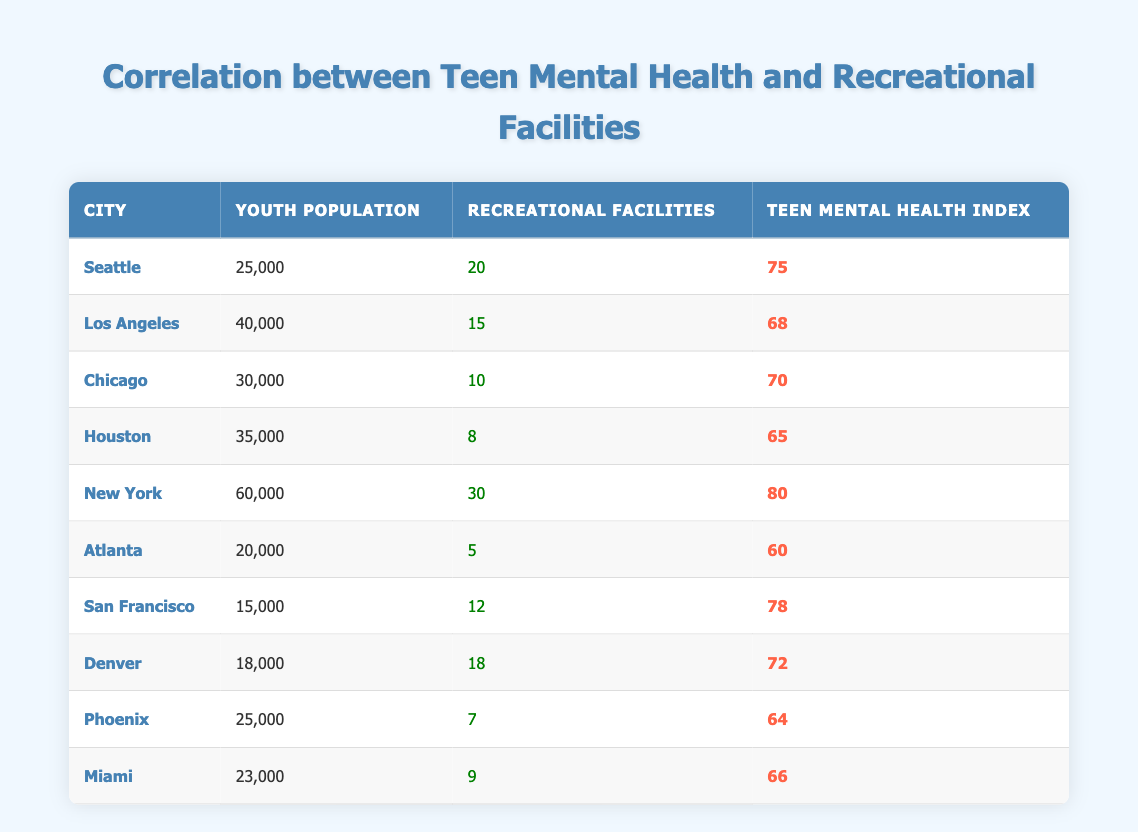What is the teen mental health index for New York? According to the table, the teen mental health index for New York is listed as 80.
Answer: 80 How many recreational facilities are available in Seattle? The table shows that there are 20 recreational facilities in Seattle.
Answer: 20 Which city has the highest recreational facilities? By scanning through the table, New York has the highest number of recreational facilities with 30.
Answer: New York What is the average teen mental health index for cities with more than 15 recreational facilities? First, identify the cities with more than 15 recreational facilities: New York (80), Seattle (75), and Denver (72). Then, calculate the average: (80 + 75 + 72) / 3 = 75.67.
Answer: 75.67 Is it true that Atlanta has a higher teen mental health index than Houston? The table indicates that Atlanta has a teen mental health index of 60, while Houston has an index of 65. Therefore, this statement is false.
Answer: No What is the difference in the number of recreational facilities between the city with the most and the city with the least? New York has the most with 30 facilities and Atlanta has the least with 5. The difference is 30 - 5 = 25.
Answer: 25 Which city has the lowest teen mental health index, and what is that value? The table shows that Atlanta has the lowest teen mental health index of 60.
Answer: Atlanta, 60 If we combine the youth populations of Houston and Miami, what is the total? Houston has a youth population of 35,000 and Miami has 23,000, so the total youth population is 35,000 + 23,000 = 58,000.
Answer: 58,000 Is there a correlation between the number of recreational facilities and the teen mental health index? Reviewing the table, as the number of recreational facilities increases, the teen mental health index seems to increase too, with higher indices corresponding to cities with more facilities, suggesting a positive correlation.
Answer: Yes 